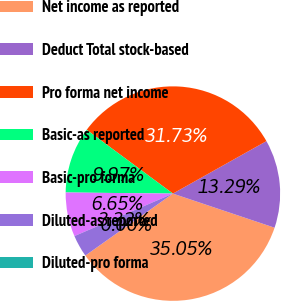Convert chart to OTSL. <chart><loc_0><loc_0><loc_500><loc_500><pie_chart><fcel>Net income as reported<fcel>Deduct Total stock-based<fcel>Pro forma net income<fcel>Basic-as reported<fcel>Basic-pro forma<fcel>Diluted-as reported<fcel>Diluted-pro forma<nl><fcel>35.05%<fcel>13.29%<fcel>31.73%<fcel>9.97%<fcel>6.65%<fcel>3.32%<fcel>0.0%<nl></chart> 